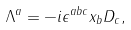<formula> <loc_0><loc_0><loc_500><loc_500>\Lambda ^ { a } = - i \epsilon ^ { a b c } x _ { b } D _ { c } ,</formula> 